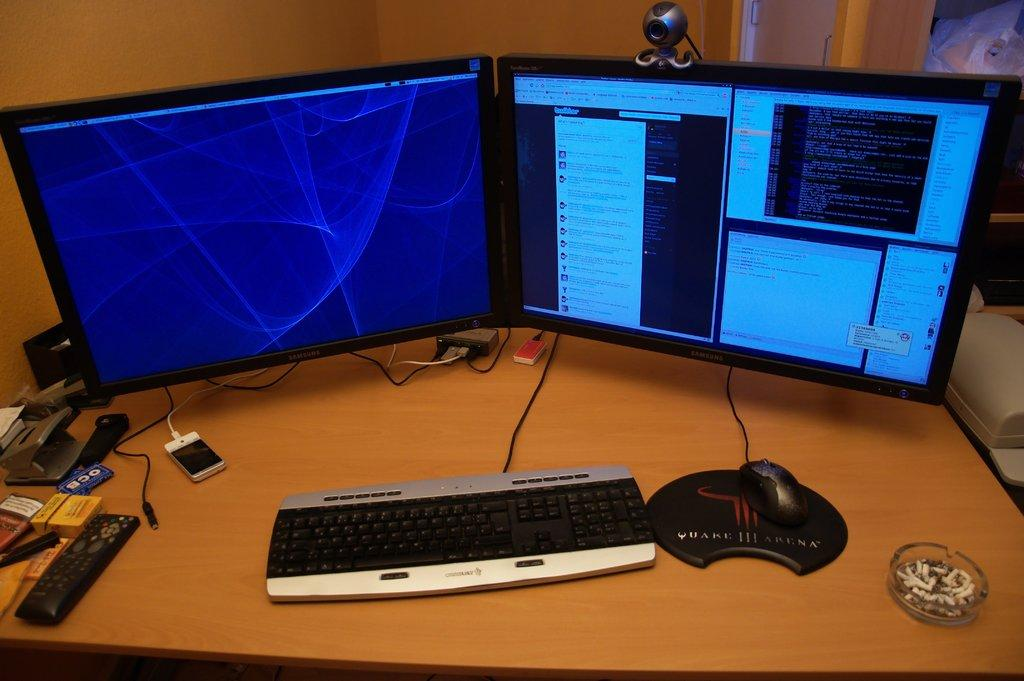Provide a one-sentence caption for the provided image. A dual monitor computer set up with a silver and black keyboard and a black gaming mouse on a Quake III Arena mousepad. 